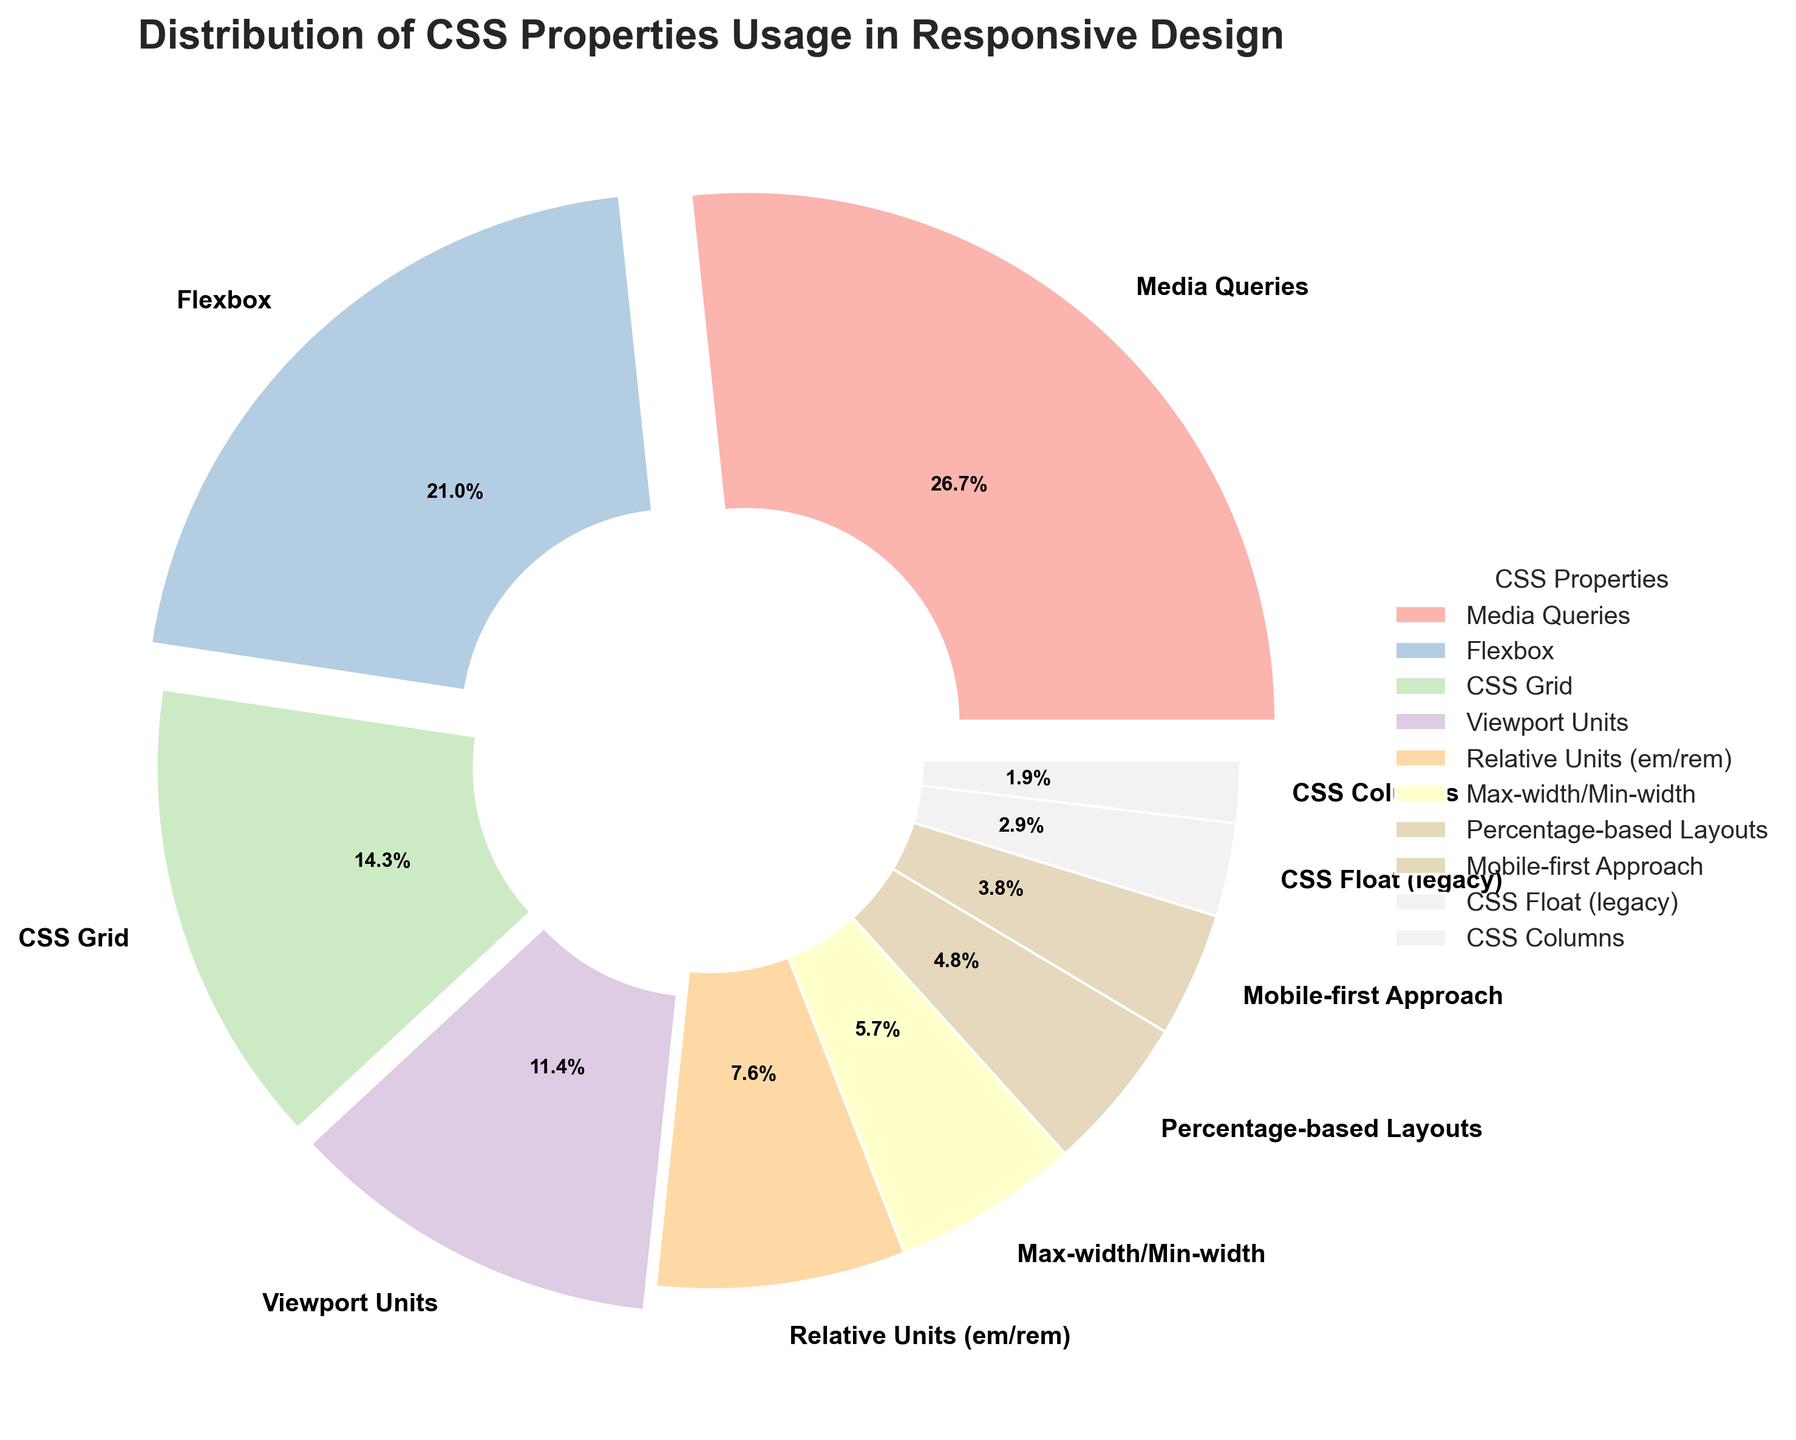What percentage of usage do Media Queries and Flexbox combined represent? To find the combined percentage of Media Queries and Flexbox, add their individual percentages: Media Queries (28%) + Flexbox (22%). Therefore, the combined percentage is 28 + 22 = 50%.
Answer: 50% Which CSS property is used more frequently, Flexbox or CSS Grid? To determine which property is used more frequently, compare the percentages: Flexbox (22%) and CSS Grid (15%). Since 22% is greater than 15%, Flexbox is used more frequently than CSS Grid.
Answer: Flexbox What are the two least used CSS properties in responsive design based on the chart? To find the two least used properties, identify the properties with the smallest percentages: CSS Float (3%) and CSS Columns (2%).
Answer: CSS Float and CSS Columns Which properties have usage percentages between 10% and 20% excluding the boundaries? To find properties with usage percentages strictly between 10% and 20%, look for values in this range. Only CSS Grid (15%) and Viewport Units (12%) fall within this range.
Answer: CSS Grid and Viewport Units What is the difference in usage between Media Queries and Mobile-first Approach? To find the difference in usage, subtract the percentage of Mobile-first Approach (4%) from Media Queries (28%): 28% - 4% = 24%.
Answer: 24% How much more frequently is Flexbox used than Max-width/Min-width? To find how much more frequently Flexbox is used compared to Max-width/Min-width, subtract the percentage of Max-width/Min-width (6%) from Flexbox (22%): 22% - 6% = 16%.
Answer: 16% What fraction of the chart does Relative Units (em/rem) represent? To find the fraction, divide the percentage of Relative Units (em/rem) (8%) by 100: 8/100 = 0.08.
Answer: 0.08 Which CSS property has the most pronounced explosion effect in the pie chart, and why? Properties are given an explosion effect based on their percentage usage: those above 20% have a higher explosion. Media Queries (28%) has the highest explosion effect due to its larger usage percentage along with Flexbox (22%), but Media Queries is the largest.
Answer: Media Queries How many CSS properties have a usage percentage greater than 10%? Count the properties with percentages greater than 10%. They are Media Queries (28%), Flexbox (22%), CSS Grid (15%), and Viewport Units (12%), totaling 4 properties.
Answer: 4 Is Percentage-based Layouts used less frequently than Media Queries? To determine if Percentage-based Layouts is used less frequently, compare their percentages: Percentage-based Layouts (5%) and Media Queries (28%). Since 5% is less than 28%, Percentage-based Layouts is used less frequently.
Answer: Yes 